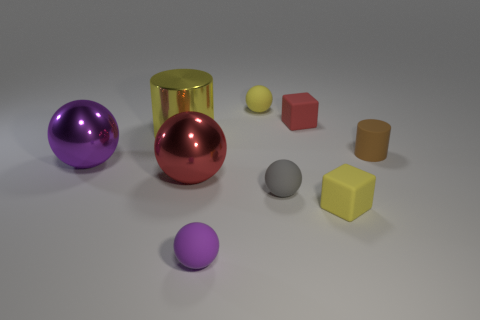Is there any other thing of the same color as the small matte cylinder?
Give a very brief answer. No. The big purple object that is the same material as the big cylinder is what shape?
Offer a very short reply. Sphere. What number of tiny yellow objects are the same shape as the purple shiny object?
Give a very brief answer. 1. What is the small yellow cube made of?
Ensure brevity in your answer.  Rubber. There is a metal cylinder; does it have the same color as the matte block in front of the yellow metallic cylinder?
Give a very brief answer. Yes. How many spheres are either tiny yellow things or large purple metal objects?
Provide a succinct answer. 2. What color is the cylinder to the left of the small purple ball?
Provide a succinct answer. Yellow. How many purple matte spheres are the same size as the metal cylinder?
Keep it short and to the point. 0. Does the yellow thing that is in front of the brown rubber cylinder have the same shape as the red rubber thing behind the tiny gray matte object?
Your answer should be compact. Yes. There is a small ball that is behind the metallic object to the right of the big metallic thing that is behind the brown matte cylinder; what is it made of?
Your response must be concise. Rubber. 